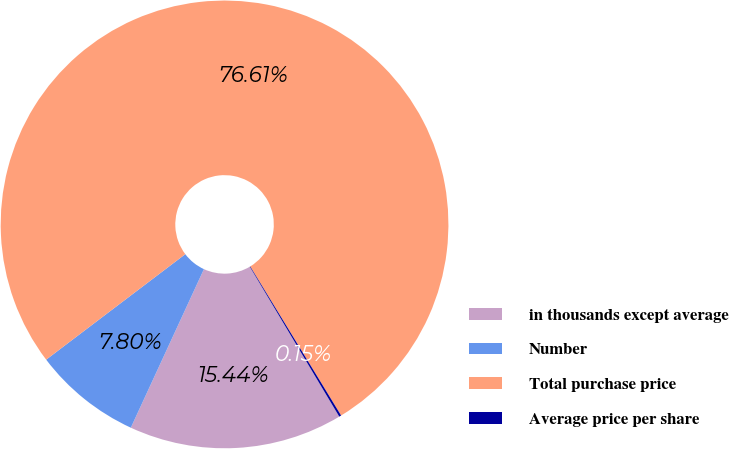Convert chart to OTSL. <chart><loc_0><loc_0><loc_500><loc_500><pie_chart><fcel>in thousands except average<fcel>Number<fcel>Total purchase price<fcel>Average price per share<nl><fcel>15.44%<fcel>7.8%<fcel>76.61%<fcel>0.15%<nl></chart> 